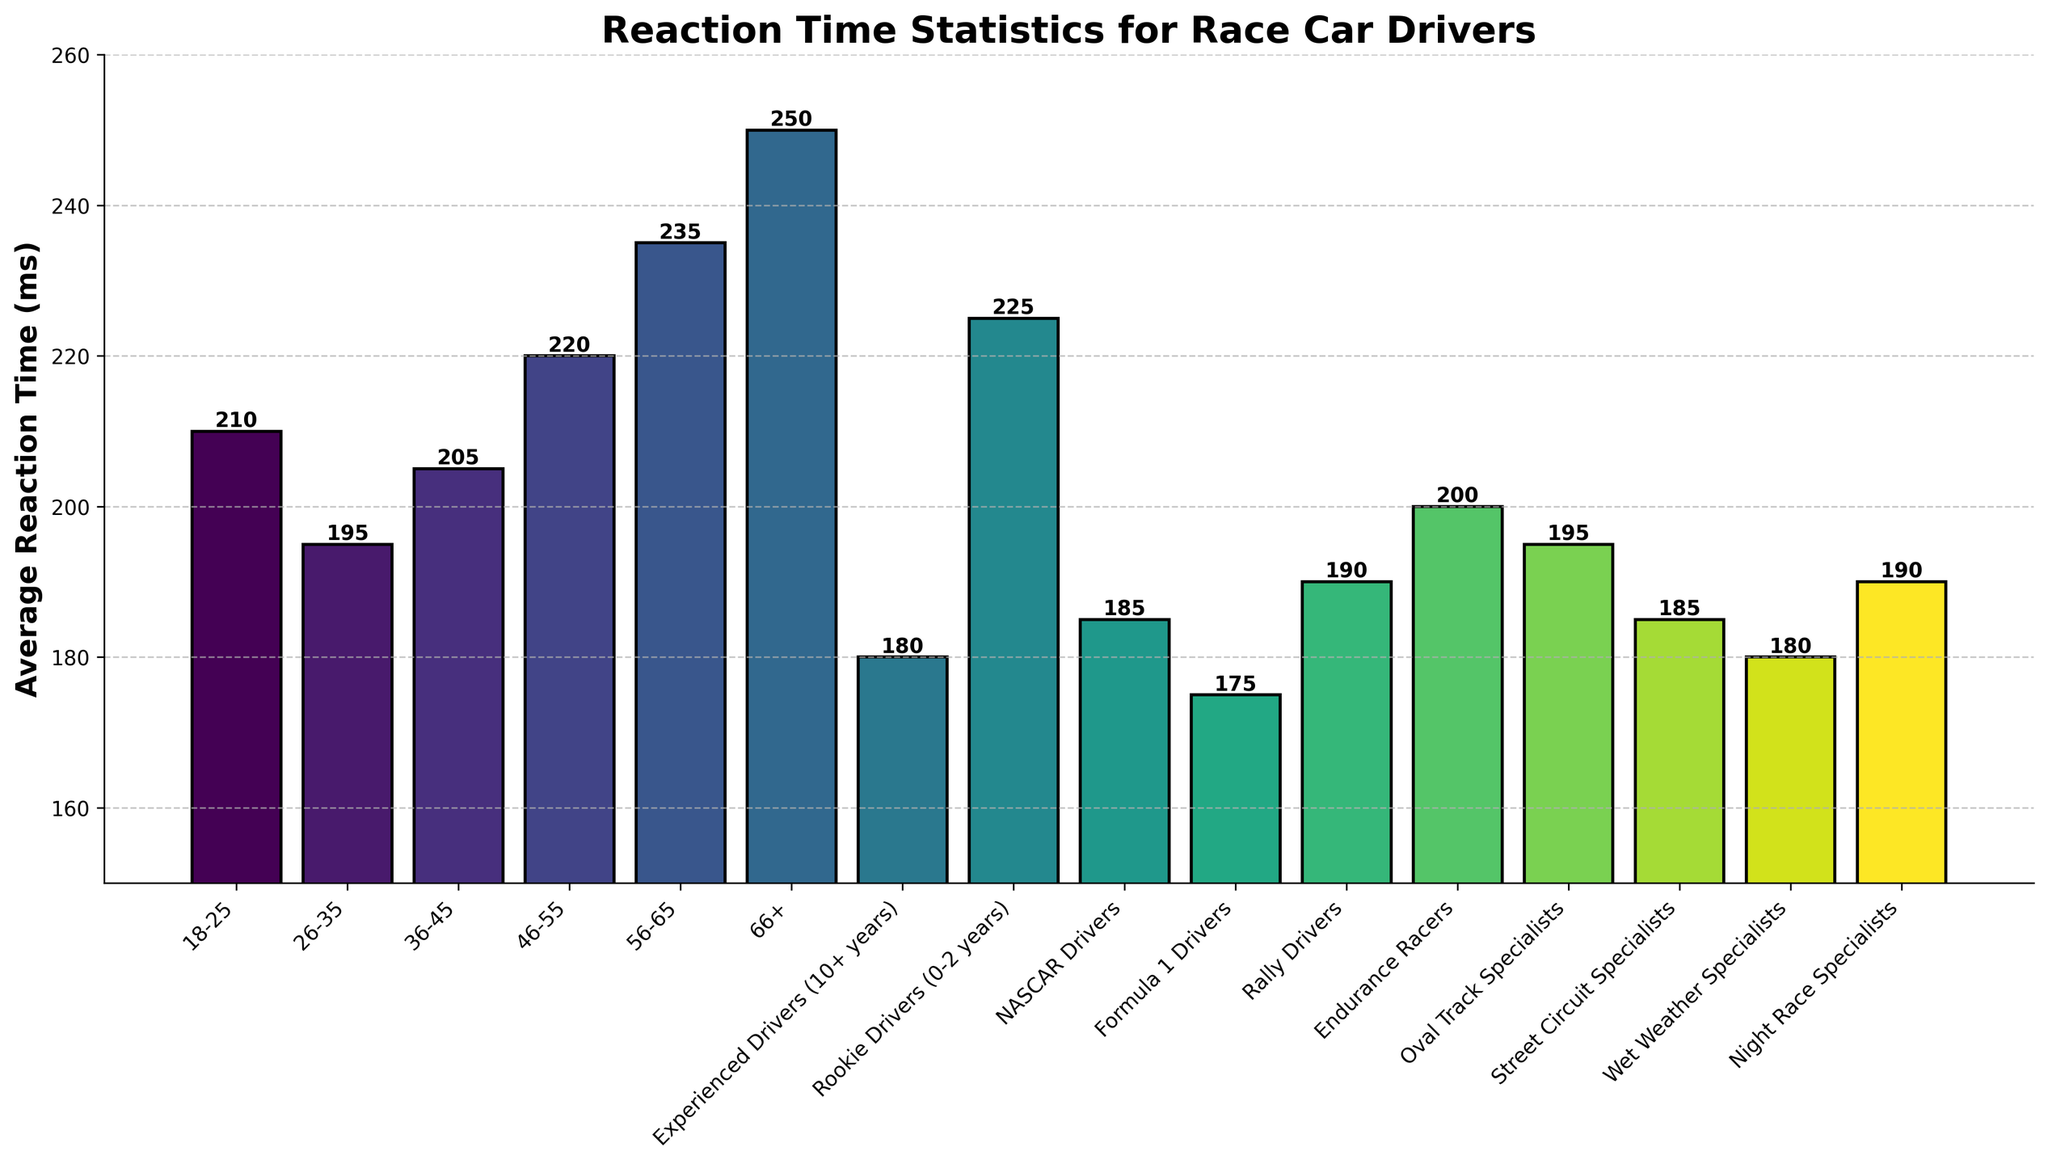What age group has the best reaction time? The best reaction time is indicated by the smallest average reaction time value. From the bar chart, the 26-35 age group has the lowest average reaction time of 195 ms.
Answer: 26-35 Which specialist drivers have reaction times equal to or better than experienced drivers? Experienced Drivers have an average reaction time of 180 ms. Wet Weather Specialists and Formula 1 Drivers also have an average reaction time of 180 ms or less.
Answer: Wet Weather Specialists, Formula 1 Drivers By how much is the reaction time of 56-65 age group greater than the reaction time of 36-45 age group? The 56-65 age group has an average reaction time of 235 ms and the 36-45 age group has 205 ms. The difference is 235 ms - 205 ms = 30 ms.
Answer: 30 ms Which group has the highest average reaction time and what is the value? The highest average reaction time can be identified by the tallest bar. The 66+ age group has the highest reaction time of 250 ms.
Answer: 66+, 250 ms Are NASCAR Drivers faster than Rookie Drivers in terms of reaction time? The reaction time for NASCAR Drivers is 185 ms, while for Rookie Drivers it is 225 ms. Since 185 ms is less than 225 ms, NASCAR Drivers are faster in reaction time.
Answer: Yes What's the difference in reaction time between the fastest age group and the fastest specialist drivers? The fastest age group is 26-35 with 195 ms and the fastest specialist drivers are Formula 1 Drivers with 175 ms. The difference is 195 ms - 175 ms = 20 ms.
Answer: 20 ms What's the combined reaction time of Night Race Specialists and Rally Drivers? Summing the reaction times of Night Race Specialists (190 ms) and Rally Drivers (190 ms) yields 190 ms + 190 ms = 380 ms.
Answer: 380 ms Which two age groups have the closest average reaction time? By comparing the values, it is evident that the 18-25 (210 ms) and 36-45 (205 ms) age groups have the closest average reaction times, with a difference of just 5 ms.
Answer: 18-25, 36-45 By what percentage is the reaction time of Rookie Drivers higher than that of Experienced Drivers? Calculation: ((225 ms - 180 ms) / 180 ms) * 100% = 25%. Rookie Drivers' reaction time is 25% higher than Experienced Drivers.
Answer: 25% What is the average reaction time across all the age groups? Summing up the reaction times of all age groups: 210 ms + 195 ms + 205 ms + 220 ms + 235 ms + 250 ms = 1315 ms. The average is 1315 ms / 6 = 219.17 ms.
Answer: 219.17 ms 